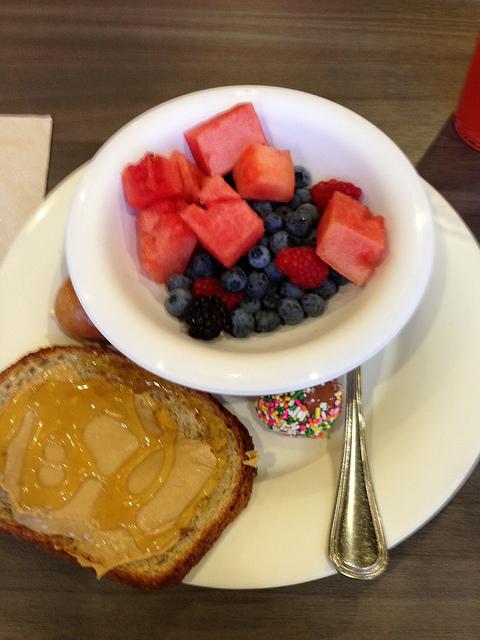What fruit can be seen?
Short answer required. Watermelon, blueberry, blackberry, strawberry. What is inside of the bowl?
Write a very short answer. Fruit. What is in the bowl?
Be succinct. Fruit. What color is the bowl?
Keep it brief. White. How many kinds of fruit are in the picture?
Be succinct. 4. How many plates are in the picture?
Give a very brief answer. 1. Is any of the fruit cut into pieces?
Give a very brief answer. Yes. Is this a vegan meal?
Short answer required. Yes. Are there more fruits in the bowl than outside the bowl?
Give a very brief answer. Yes. What fruit is on the plate?
Give a very brief answer. Watermelon and blueberries. Does it look like honey is on the bread?
Write a very short answer. Yes. What is the bowl?
Give a very brief answer. Fruit. What is on the toast?
Give a very brief answer. Honey. How many watermelon slices are there?
Keep it brief. 6. Is this  a healthy breakfast?
Write a very short answer. Yes. What color is the dinnerware?
Give a very brief answer. White. Are there any beverages in this scene?
Be succinct. No. What color is the fruit?
Keep it brief. Red. What kind of fruit is this?
Answer briefly. Watermelon. What dish is this?
Concise answer only. Fruit. Is there a mouse by the food?
Be succinct. No. How many fruits are there?
Write a very short answer. 4. What type of fruit is pictured?
Answer briefly. Watermelon and blueberries. What is the red stuff on the plate?
Keep it brief. Watermelon. Are there raspberries on the tray?
Keep it brief. Yes. What color is the plate?
Answer briefly. White. What is in the bowl on the right?
Short answer required. Fruit. How many types of fruit are on the plate?
Quick response, please. 4. How eating utensil is on the plate?
Keep it brief. 1. What kind of fruit is on the plate?
Short answer required. Berries and watermelon. Where are the strawberries?
Short answer required. In bowl. What kind of fruit is next to the bowl?
Answer briefly. Watermelon and blueberries. What is the occasion?
Keep it brief. Breakfast. 